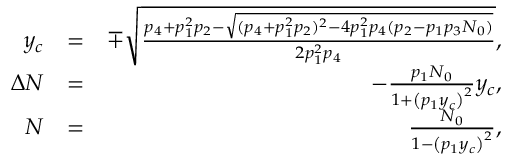Convert formula to latex. <formula><loc_0><loc_0><loc_500><loc_500>\begin{array} { r l r } { y _ { c } } & { = } & { \mp \sqrt { \frac { p _ { 4 } + p _ { 1 } ^ { 2 } p _ { 2 } - \sqrt { ( p _ { 4 } + p _ { 1 } ^ { 2 } p _ { 2 } ) ^ { 2 } - 4 p _ { 1 } ^ { 2 } p _ { 4 } ( p _ { 2 } - p _ { 1 } p _ { 3 } N _ { 0 } ) } } { 2 p _ { 1 } ^ { 2 } p _ { 4 } } } , } \\ { \Delta N } & { = } & { - \frac { p _ { 1 } N _ { 0 } } { 1 + \left ( p _ { 1 } y _ { c } \right ) ^ { 2 } } y _ { c } , } \\ { N } & { = } & { \frac { N _ { 0 } } { 1 - \left ( p _ { 1 } y _ { c } \right ) ^ { 2 } } , } \end{array}</formula> 